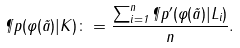<formula> <loc_0><loc_0><loc_500><loc_500>\P p ( \varphi ( \vec { a } ) | K ) \colon = \frac { \sum _ { i = 1 } ^ { n } \P p ^ { \prime } ( \varphi ( \vec { a } ) | L _ { i } ) } { n } .</formula> 